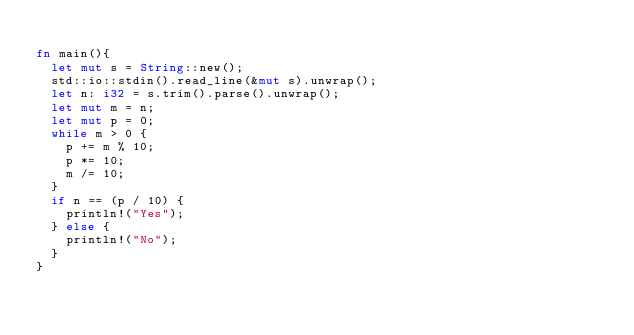Convert code to text. <code><loc_0><loc_0><loc_500><loc_500><_Rust_>
fn main(){
	let mut s = String::new();
	std::io::stdin().read_line(&mut s).unwrap();
	let n: i32 = s.trim().parse().unwrap();
	let mut m = n;
	let mut p = 0;
	while m > 0 {
		p += m % 10;
		p *= 10;
		m /= 10;
	}
	if n == (p / 10) {
		println!("Yes");
	} else {
		println!("No");
	}
}
</code> 